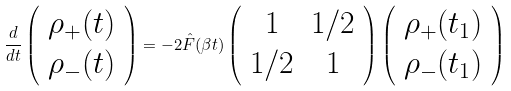<formula> <loc_0><loc_0><loc_500><loc_500>\frac { d } { d t } \left ( \begin{array} { l } \rho _ { + } ( t ) \\ \rho _ { - } ( t ) \end{array} \right ) = - 2 \hat { F } ( \beta t ) \left ( \begin{array} { c c } 1 & 1 / 2 \\ 1 / 2 & 1 \end{array} \right ) \left ( \begin{array} { c } \rho _ { + } ( t _ { 1 } ) \\ \rho _ { - } ( t _ { 1 } ) \end{array} \right )</formula> 